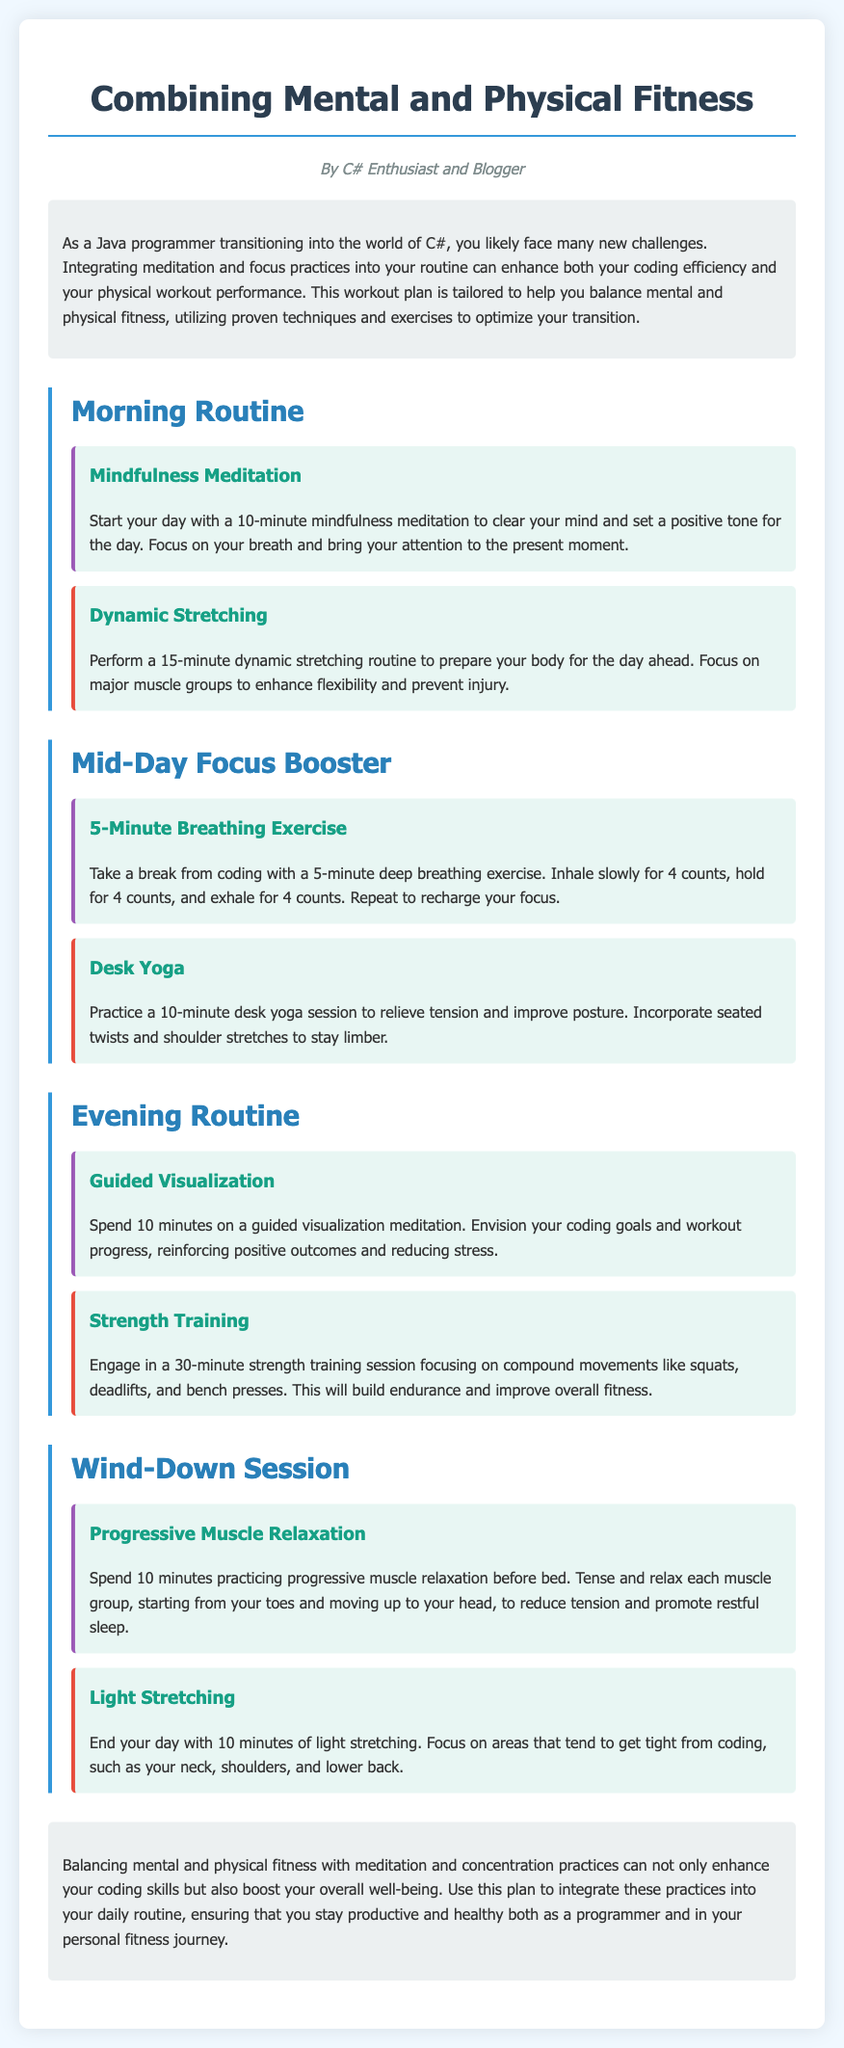What is the title of the document? The title is displayed at the top of the document, clearly indicating the main topic.
Answer: Combining Mental and Physical Fitness Who is the author of the document? The author is mentioned in the introduction section, reflecting their background.
Answer: C# Enthusiast and Blogger How long should the mindfulness meditation last? The duration of the mindfulness meditation is specified in the morning routine section.
Answer: 10 minutes What type of exercise is recommended for the evening routine? The evening routine includes a specific type of workout aimed at building strength.
Answer: Strength Training How long should the desk yoga session be? The duration is included in the description of the mid-day focus booster section.
Answer: 10 minutes What is the main purpose of the workout plan? The purpose is summarized in the introduction and conclusion sections, focusing on the benefits.
Answer: Enhance coding efficiency and physical performance How many exercises are listed under the evening routine? The evening routine section details the number of distinct activities recommended.
Answer: 2 exercises What is the first activity suggested in the morning routine? The morning routine starts with a particular practice aimed at mental clarity.
Answer: Mindfulness Meditation What technique is employed in the wind-down session? The wind-down session features a specific relaxation method to promote sleep.
Answer: Progressive Muscle Relaxation 